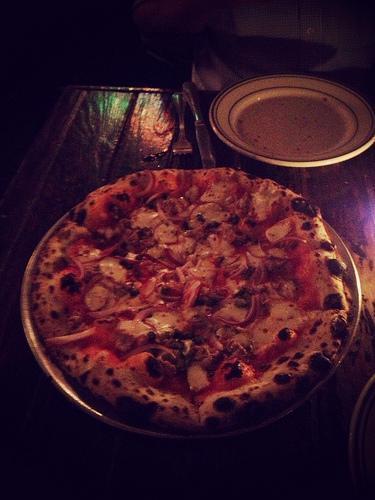How many plates are on the table?
Give a very brief answer. 2. 